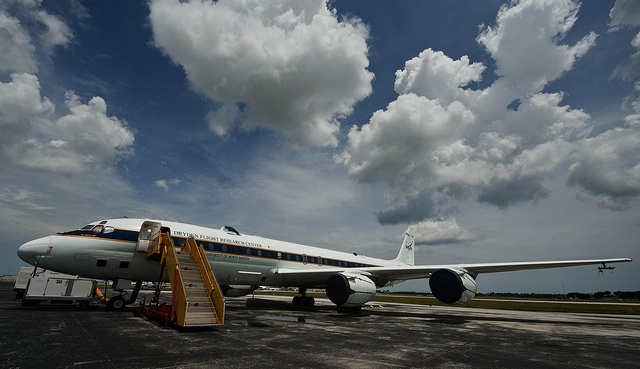Describe the objects in this image and their specific colors. I can see a airplane in gray, black, lightgray, and darkgray tones in this image. 